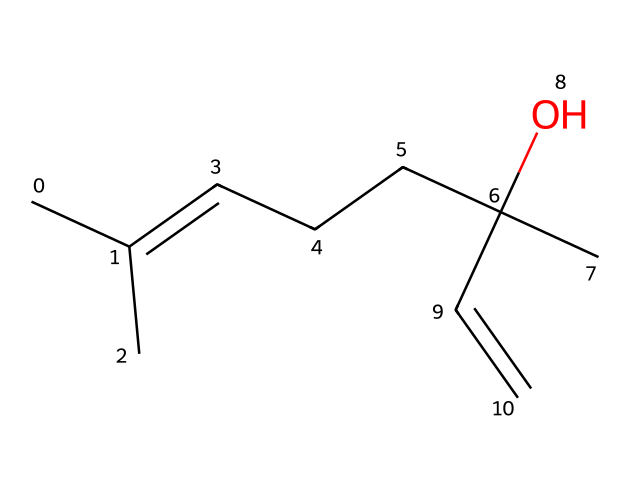What is the molecular formula of linalool? The molecular formula can be determined by counting the number of each type of atom in the SMILES representation. The structure contains 10 carbon (C) atoms, 18 hydrogen (H) atoms, and 1 oxygen (O) atom. Therefore, the molecular formula is C10H18O.
Answer: C10H18O How many double bonds are present in linalool? By analyzing the SMILES structure, we can find double bonds by looking for carbon atoms connected with equals signs. There are 2 double bonds present in linalool, indicated in the structure.
Answer: 2 What type of functional group is indicated in linalool? The SMILES representation shows a hydroxyl group (-OH) present in the structure, which indicates that linalool contains an alcohol function. This is important for its characteristics.
Answer: alcohol Which part of linalool contributes to its floral scent? The characteristic floral scent of linalool can be attributed to the arrangement of the double bonds and the presence of the hydroxyl group in its structure, which creates a specific molecular shape that interacts with scent receptors.
Answer: double bonds and hydroxyl group How many stereocenters does linalool have? A stereocenter is a carbon atom bound to four different groups. In the provided structure, there is one such center at the carbon with the hydroxyl group attached. This makes the molecule chiral.
Answer: 1 Is linalool classified as a monoterpene or a sesquiterpene? Linalool is classified based on its molecular structure and the number of carbon atoms. Since it contains 10 carbon atoms, it falls under the category of monoterpenes.
Answer: monoterpene 